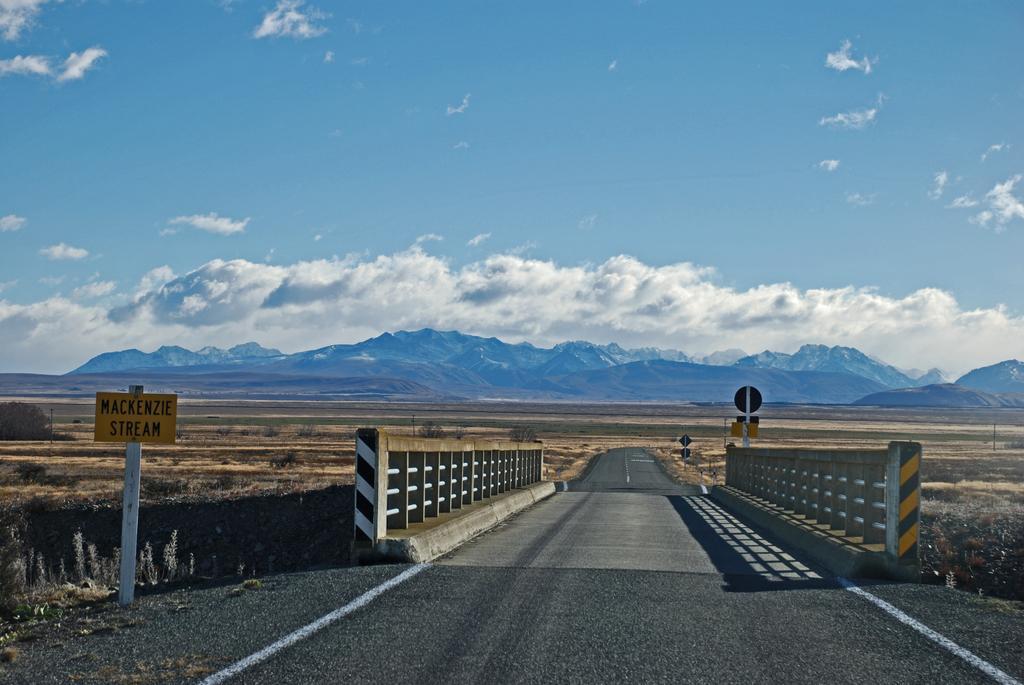Please provide a concise description of this image. In the image we can see there is a road and there is a bridge. There is a hoarding kept on the road and behind there are mountains. There is a cloudy sky. 